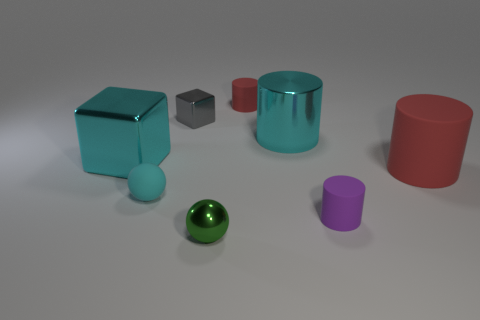Do the small red rubber object and the purple rubber thing have the same shape?
Provide a short and direct response. Yes. What size is the metal object that is the same color as the metallic cylinder?
Ensure brevity in your answer.  Large. There is a matte object that is to the left of the small metal thing behind the tiny shiny sphere; what shape is it?
Provide a succinct answer. Sphere. Does the purple matte thing have the same shape as the big cyan thing to the left of the green metallic object?
Give a very brief answer. No. There is another ball that is the same size as the green metal sphere; what color is it?
Offer a terse response. Cyan. Are there fewer gray shiny things that are in front of the big cyan block than gray shiny objects that are in front of the metal ball?
Your answer should be very brief. No. There is a cyan object that is in front of the red rubber cylinder on the right side of the metallic object right of the green metal sphere; what is its shape?
Provide a short and direct response. Sphere. There is a tiny metal thing that is in front of the big shiny block; does it have the same color as the rubber cylinder left of the purple object?
Offer a terse response. No. There is a small object that is the same color as the large rubber cylinder; what shape is it?
Provide a short and direct response. Cylinder. How many shiny things are cyan spheres or small yellow cylinders?
Your response must be concise. 0. 